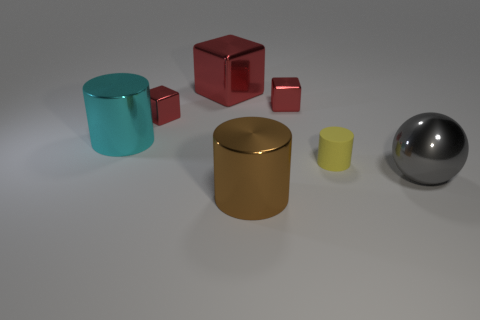There is a red object that is to the right of the brown metallic thing; does it have the same shape as the big metal object that is in front of the big gray ball?
Your answer should be very brief. No. What number of other objects are the same size as the matte object?
Your response must be concise. 2. The ball is what size?
Your answer should be very brief. Large. Does the thing that is in front of the big gray object have the same material as the ball?
Keep it short and to the point. Yes. There is another big object that is the same shape as the brown object; what is its color?
Your answer should be compact. Cyan. There is a tiny cube that is on the right side of the big brown cylinder; is its color the same as the sphere?
Offer a very short reply. No. Are there any small yellow objects right of the tiny yellow cylinder?
Offer a very short reply. No. There is a cylinder that is both on the left side of the small matte thing and behind the sphere; what color is it?
Provide a short and direct response. Cyan. What is the size of the shiny cylinder to the right of the large shiny cylinder that is behind the large sphere?
Your response must be concise. Large. How many balls are either large brown things or tiny red things?
Ensure brevity in your answer.  0. 